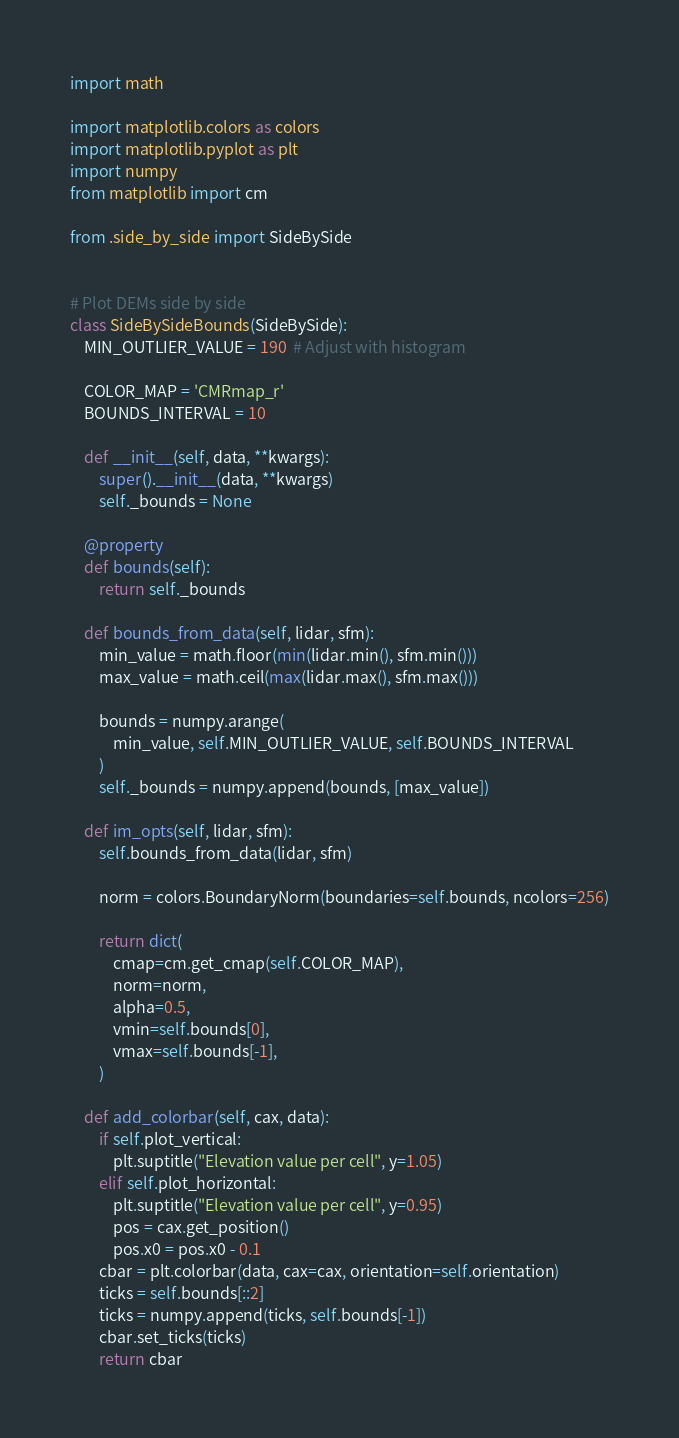<code> <loc_0><loc_0><loc_500><loc_500><_Python_>import math

import matplotlib.colors as colors
import matplotlib.pyplot as plt
import numpy
from matplotlib import cm

from .side_by_side import SideBySide


# Plot DEMs side by side
class SideBySideBounds(SideBySide):
    MIN_OUTLIER_VALUE = 190  # Adjust with histogram

    COLOR_MAP = 'CMRmap_r'
    BOUNDS_INTERVAL = 10

    def __init__(self, data, **kwargs):
        super().__init__(data, **kwargs)
        self._bounds = None

    @property
    def bounds(self):
        return self._bounds

    def bounds_from_data(self, lidar, sfm):
        min_value = math.floor(min(lidar.min(), sfm.min()))
        max_value = math.ceil(max(lidar.max(), sfm.max()))

        bounds = numpy.arange(
            min_value, self.MIN_OUTLIER_VALUE, self.BOUNDS_INTERVAL
        )
        self._bounds = numpy.append(bounds, [max_value])

    def im_opts(self, lidar, sfm):
        self.bounds_from_data(lidar, sfm)

        norm = colors.BoundaryNorm(boundaries=self.bounds, ncolors=256)

        return dict(
            cmap=cm.get_cmap(self.COLOR_MAP),
            norm=norm,
            alpha=0.5,
            vmin=self.bounds[0],
            vmax=self.bounds[-1],
        )

    def add_colorbar(self, cax, data):
        if self.plot_vertical:
            plt.suptitle("Elevation value per cell", y=1.05)
        elif self.plot_horizontal:
            plt.suptitle("Elevation value per cell", y=0.95)
            pos = cax.get_position()
            pos.x0 = pos.x0 - 0.1
        cbar = plt.colorbar(data, cax=cax, orientation=self.orientation)
        ticks = self.bounds[::2]
        ticks = numpy.append(ticks, self.bounds[-1])
        cbar.set_ticks(ticks)
        return cbar
</code> 